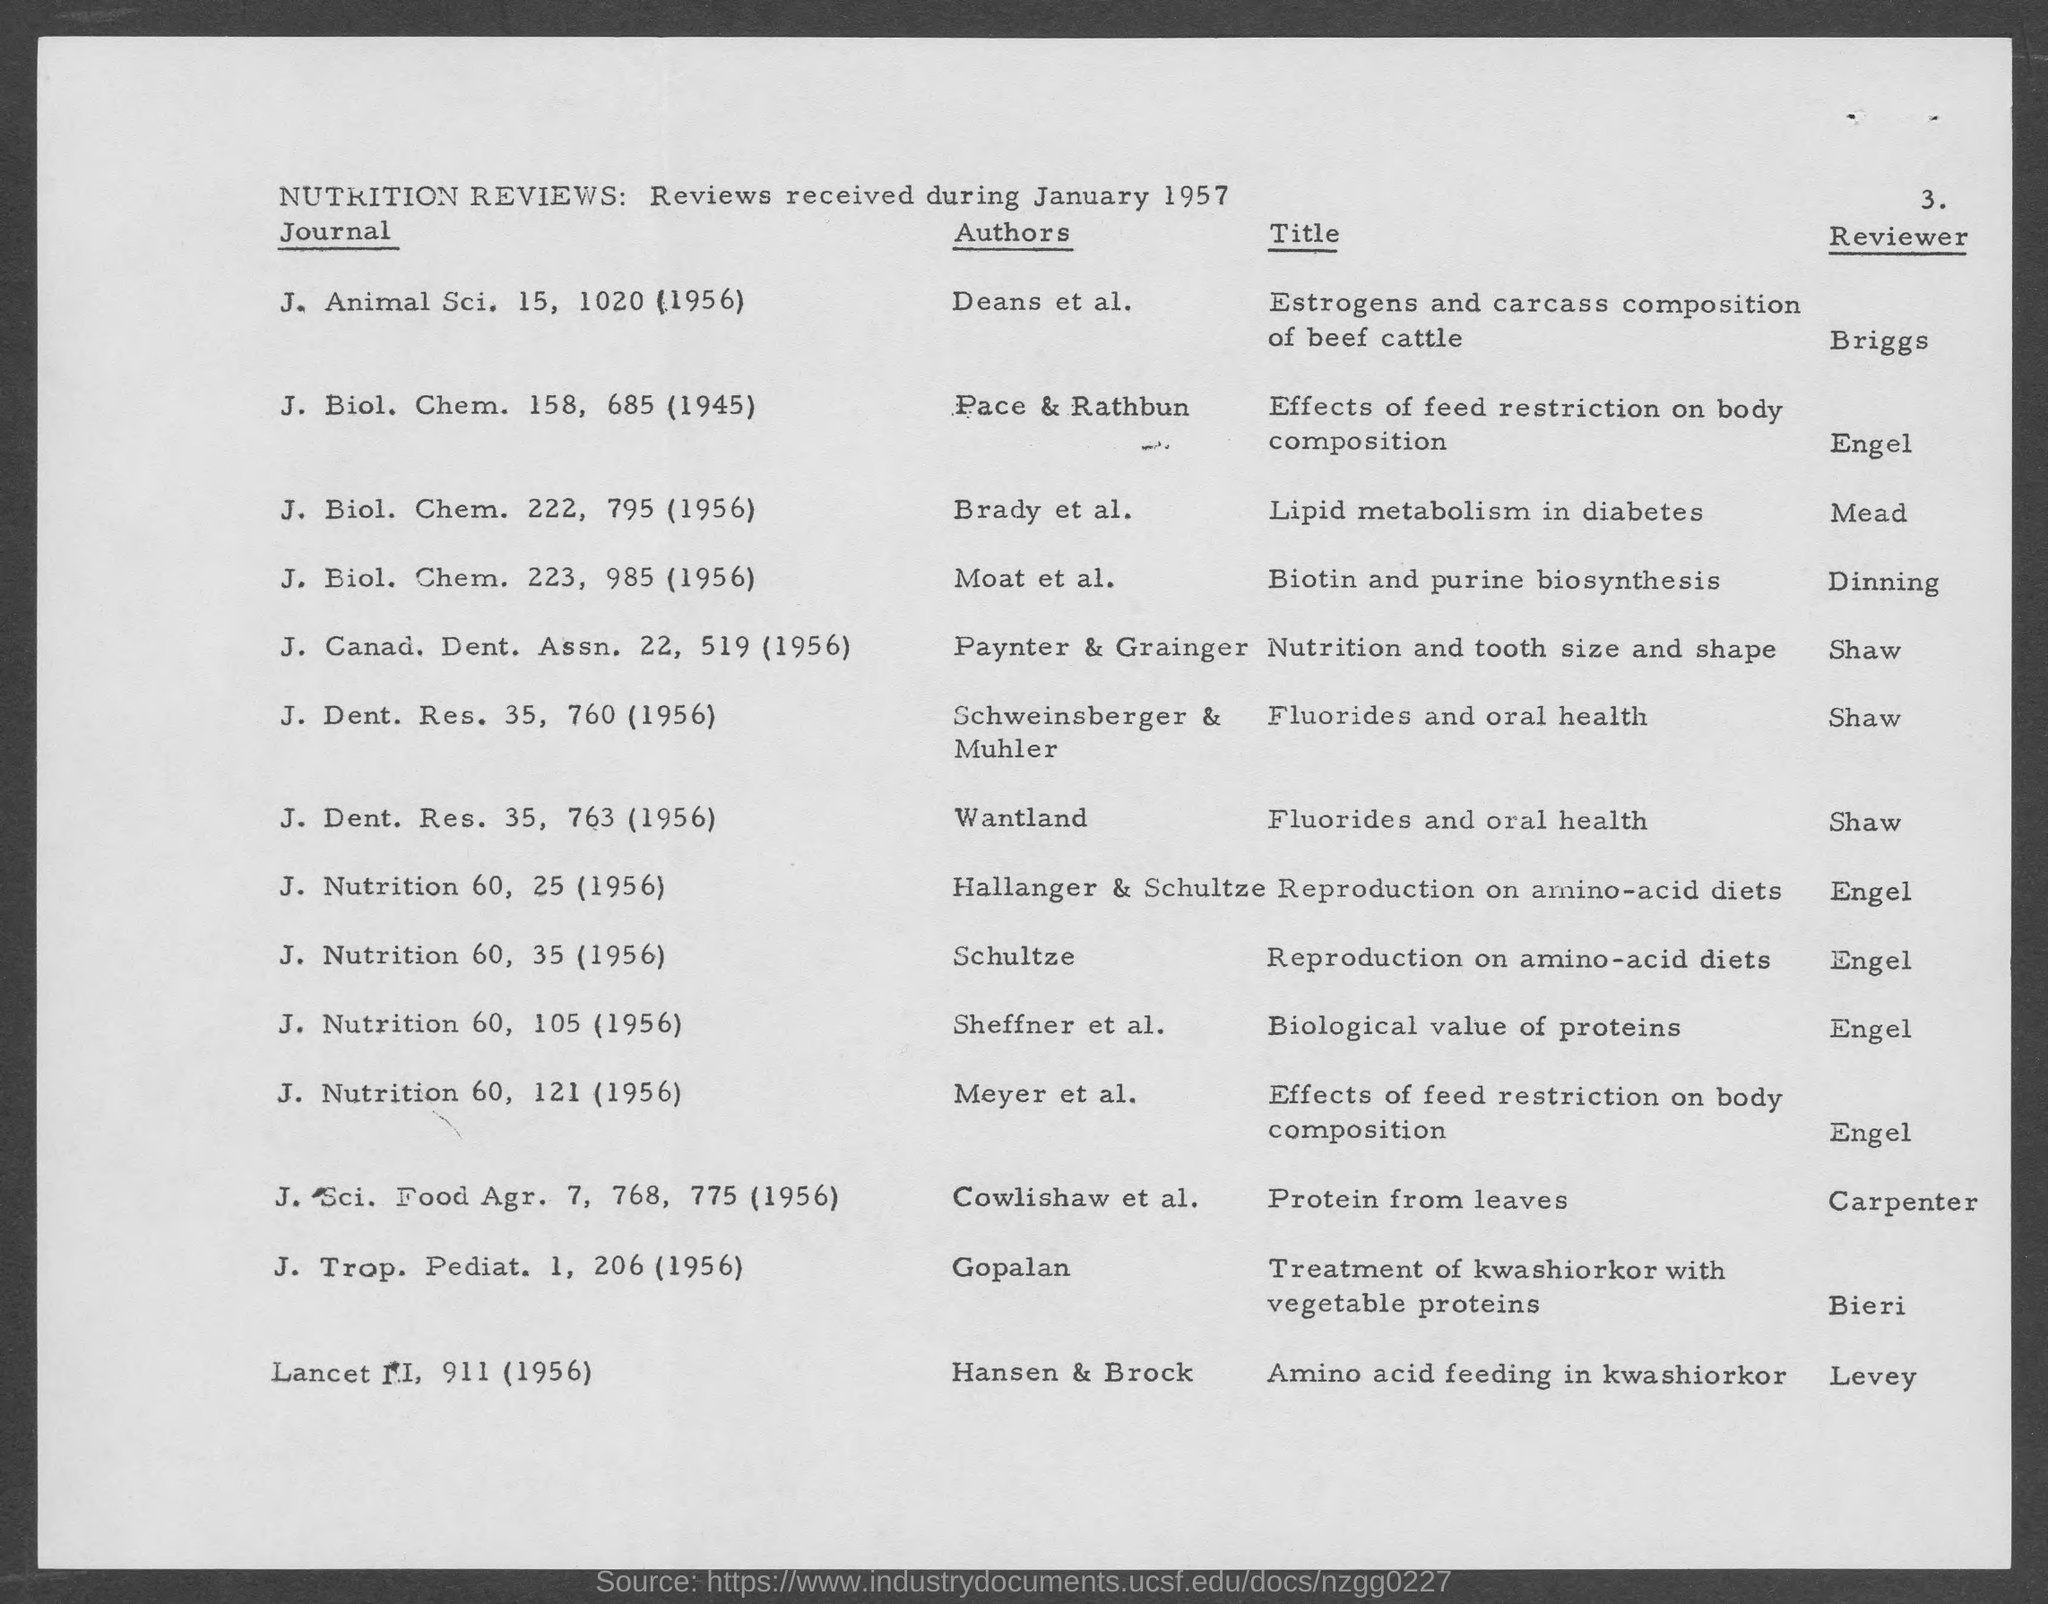Highlight a few significant elements in this photo. The author of the journal "J. Nutrition 60, 35 (1956)" is Schultze. The journal titled "Journal of Nutrition 60, 121" was authored by Meyer et al. in 1956. The author of the journal "J. Trop. Pediat. 1, 206 (1956)" is Gopalan. The reviewer of the journal J. Dent. Res. 35, 763 (1956) is Shaw. The reviewer of the journal "Journal of Nutrition" 60, 35 (1956) is Engel. 